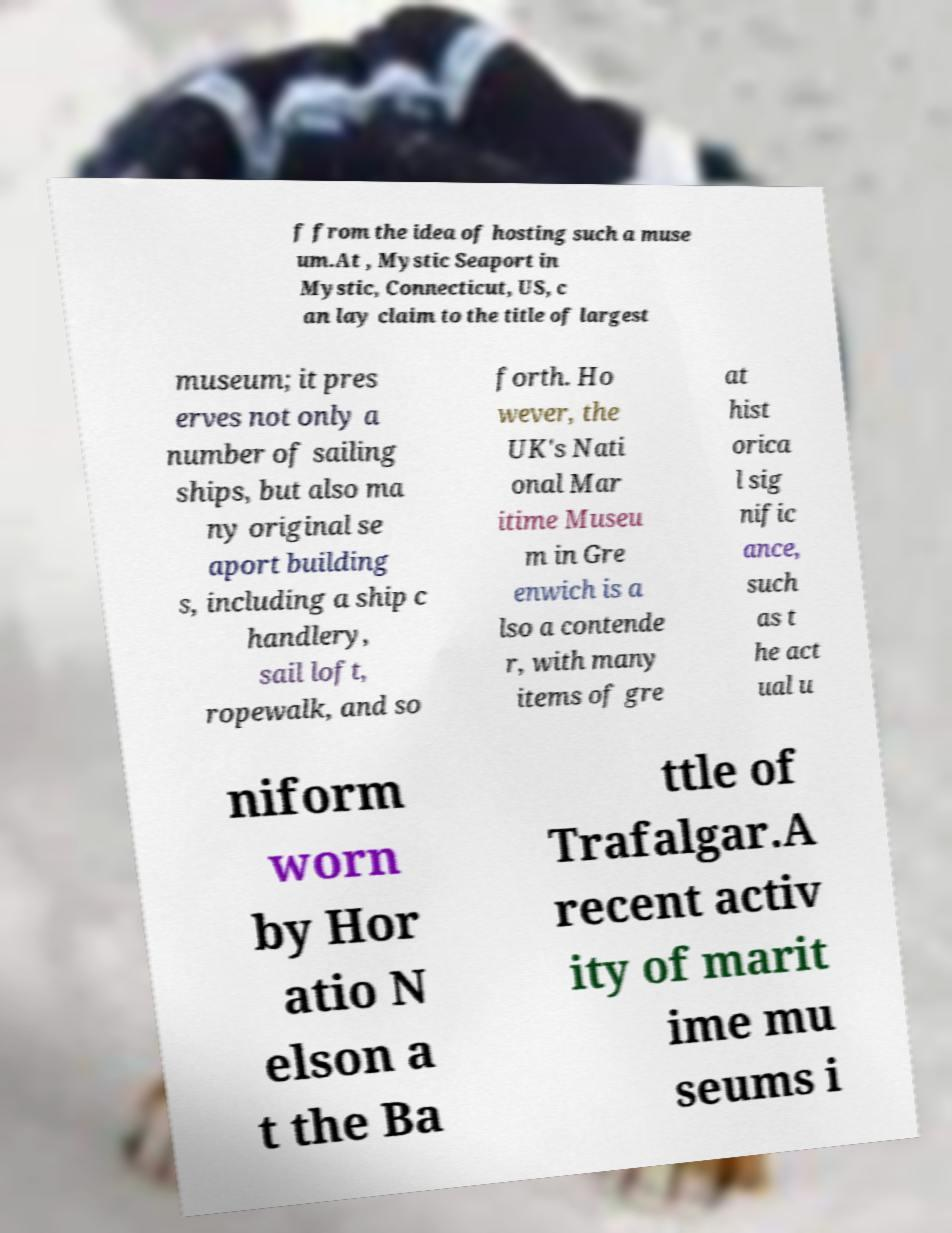Could you assist in decoding the text presented in this image and type it out clearly? f from the idea of hosting such a muse um.At , Mystic Seaport in Mystic, Connecticut, US, c an lay claim to the title of largest museum; it pres erves not only a number of sailing ships, but also ma ny original se aport building s, including a ship c handlery, sail loft, ropewalk, and so forth. Ho wever, the UK's Nati onal Mar itime Museu m in Gre enwich is a lso a contende r, with many items of gre at hist orica l sig nific ance, such as t he act ual u niform worn by Hor atio N elson a t the Ba ttle of Trafalgar.A recent activ ity of marit ime mu seums i 